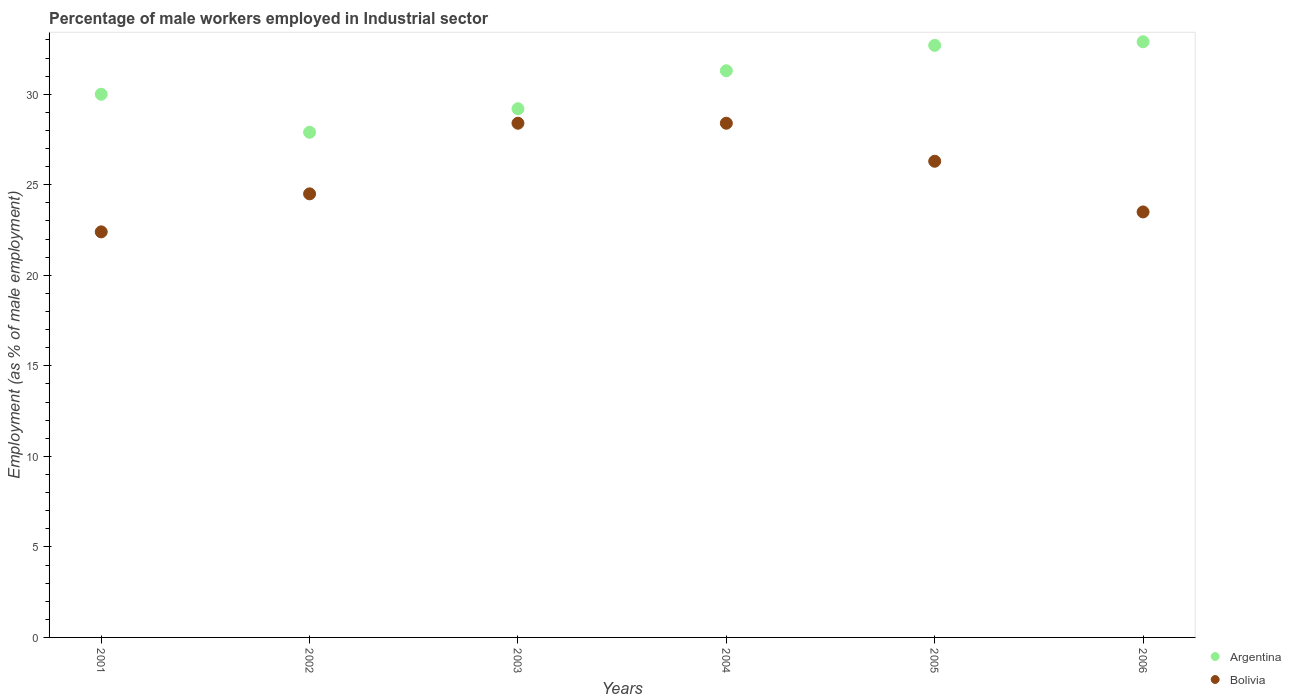How many different coloured dotlines are there?
Provide a succinct answer. 2. What is the percentage of male workers employed in Industrial sector in Argentina in 2003?
Keep it short and to the point. 29.2. Across all years, what is the maximum percentage of male workers employed in Industrial sector in Bolivia?
Your answer should be compact. 28.4. Across all years, what is the minimum percentage of male workers employed in Industrial sector in Bolivia?
Offer a terse response. 22.4. In which year was the percentage of male workers employed in Industrial sector in Bolivia maximum?
Offer a terse response. 2003. What is the total percentage of male workers employed in Industrial sector in Bolivia in the graph?
Offer a terse response. 153.5. What is the difference between the percentage of male workers employed in Industrial sector in Bolivia in 2002 and that in 2006?
Provide a succinct answer. 1. What is the difference between the percentage of male workers employed in Industrial sector in Bolivia in 2006 and the percentage of male workers employed in Industrial sector in Argentina in 2005?
Offer a terse response. -9.2. What is the average percentage of male workers employed in Industrial sector in Bolivia per year?
Your answer should be very brief. 25.58. In the year 2004, what is the difference between the percentage of male workers employed in Industrial sector in Bolivia and percentage of male workers employed in Industrial sector in Argentina?
Your answer should be very brief. -2.9. In how many years, is the percentage of male workers employed in Industrial sector in Argentina greater than 18 %?
Keep it short and to the point. 6. What is the ratio of the percentage of male workers employed in Industrial sector in Bolivia in 2002 to that in 2006?
Keep it short and to the point. 1.04. Is the percentage of male workers employed in Industrial sector in Bolivia in 2005 less than that in 2006?
Keep it short and to the point. No. What is the difference between the highest and the second highest percentage of male workers employed in Industrial sector in Bolivia?
Your answer should be compact. 0. What is the difference between the highest and the lowest percentage of male workers employed in Industrial sector in Bolivia?
Give a very brief answer. 6. Is the percentage of male workers employed in Industrial sector in Argentina strictly less than the percentage of male workers employed in Industrial sector in Bolivia over the years?
Ensure brevity in your answer.  No. How many years are there in the graph?
Offer a terse response. 6. Are the values on the major ticks of Y-axis written in scientific E-notation?
Provide a succinct answer. No. Where does the legend appear in the graph?
Make the answer very short. Bottom right. How are the legend labels stacked?
Provide a short and direct response. Vertical. What is the title of the graph?
Your response must be concise. Percentage of male workers employed in Industrial sector. What is the label or title of the Y-axis?
Your answer should be compact. Employment (as % of male employment). What is the Employment (as % of male employment) of Bolivia in 2001?
Your answer should be very brief. 22.4. What is the Employment (as % of male employment) of Argentina in 2002?
Your answer should be compact. 27.9. What is the Employment (as % of male employment) in Argentina in 2003?
Provide a short and direct response. 29.2. What is the Employment (as % of male employment) in Bolivia in 2003?
Offer a terse response. 28.4. What is the Employment (as % of male employment) in Argentina in 2004?
Your answer should be very brief. 31.3. What is the Employment (as % of male employment) of Bolivia in 2004?
Offer a terse response. 28.4. What is the Employment (as % of male employment) in Argentina in 2005?
Keep it short and to the point. 32.7. What is the Employment (as % of male employment) in Bolivia in 2005?
Provide a succinct answer. 26.3. What is the Employment (as % of male employment) in Argentina in 2006?
Offer a terse response. 32.9. What is the Employment (as % of male employment) in Bolivia in 2006?
Provide a succinct answer. 23.5. Across all years, what is the maximum Employment (as % of male employment) in Argentina?
Your answer should be very brief. 32.9. Across all years, what is the maximum Employment (as % of male employment) in Bolivia?
Provide a succinct answer. 28.4. Across all years, what is the minimum Employment (as % of male employment) of Argentina?
Your response must be concise. 27.9. Across all years, what is the minimum Employment (as % of male employment) in Bolivia?
Your response must be concise. 22.4. What is the total Employment (as % of male employment) of Argentina in the graph?
Offer a terse response. 184. What is the total Employment (as % of male employment) in Bolivia in the graph?
Keep it short and to the point. 153.5. What is the difference between the Employment (as % of male employment) in Bolivia in 2001 and that in 2002?
Provide a short and direct response. -2.1. What is the difference between the Employment (as % of male employment) of Bolivia in 2001 and that in 2003?
Offer a very short reply. -6. What is the difference between the Employment (as % of male employment) of Argentina in 2001 and that in 2004?
Your answer should be very brief. -1.3. What is the difference between the Employment (as % of male employment) in Bolivia in 2001 and that in 2006?
Your answer should be compact. -1.1. What is the difference between the Employment (as % of male employment) of Argentina in 2002 and that in 2003?
Provide a succinct answer. -1.3. What is the difference between the Employment (as % of male employment) in Bolivia in 2002 and that in 2003?
Offer a terse response. -3.9. What is the difference between the Employment (as % of male employment) of Bolivia in 2002 and that in 2005?
Offer a very short reply. -1.8. What is the difference between the Employment (as % of male employment) of Bolivia in 2003 and that in 2004?
Your response must be concise. 0. What is the difference between the Employment (as % of male employment) of Argentina in 2003 and that in 2005?
Your response must be concise. -3.5. What is the difference between the Employment (as % of male employment) of Bolivia in 2003 and that in 2005?
Your response must be concise. 2.1. What is the difference between the Employment (as % of male employment) in Bolivia in 2004 and that in 2006?
Keep it short and to the point. 4.9. What is the difference between the Employment (as % of male employment) in Argentina in 2005 and that in 2006?
Give a very brief answer. -0.2. What is the difference between the Employment (as % of male employment) in Argentina in 2001 and the Employment (as % of male employment) in Bolivia in 2003?
Provide a succinct answer. 1.6. What is the difference between the Employment (as % of male employment) of Argentina in 2001 and the Employment (as % of male employment) of Bolivia in 2004?
Your response must be concise. 1.6. What is the difference between the Employment (as % of male employment) in Argentina in 2001 and the Employment (as % of male employment) in Bolivia in 2005?
Make the answer very short. 3.7. What is the difference between the Employment (as % of male employment) in Argentina in 2001 and the Employment (as % of male employment) in Bolivia in 2006?
Offer a very short reply. 6.5. What is the difference between the Employment (as % of male employment) of Argentina in 2002 and the Employment (as % of male employment) of Bolivia in 2004?
Your answer should be very brief. -0.5. What is the difference between the Employment (as % of male employment) of Argentina in 2003 and the Employment (as % of male employment) of Bolivia in 2006?
Keep it short and to the point. 5.7. What is the average Employment (as % of male employment) in Argentina per year?
Offer a very short reply. 30.67. What is the average Employment (as % of male employment) of Bolivia per year?
Give a very brief answer. 25.58. In the year 2001, what is the difference between the Employment (as % of male employment) in Argentina and Employment (as % of male employment) in Bolivia?
Provide a succinct answer. 7.6. In the year 2002, what is the difference between the Employment (as % of male employment) of Argentina and Employment (as % of male employment) of Bolivia?
Your answer should be very brief. 3.4. In the year 2004, what is the difference between the Employment (as % of male employment) of Argentina and Employment (as % of male employment) of Bolivia?
Offer a terse response. 2.9. What is the ratio of the Employment (as % of male employment) of Argentina in 2001 to that in 2002?
Your answer should be very brief. 1.08. What is the ratio of the Employment (as % of male employment) in Bolivia in 2001 to that in 2002?
Give a very brief answer. 0.91. What is the ratio of the Employment (as % of male employment) in Argentina in 2001 to that in 2003?
Give a very brief answer. 1.03. What is the ratio of the Employment (as % of male employment) of Bolivia in 2001 to that in 2003?
Keep it short and to the point. 0.79. What is the ratio of the Employment (as % of male employment) of Argentina in 2001 to that in 2004?
Ensure brevity in your answer.  0.96. What is the ratio of the Employment (as % of male employment) of Bolivia in 2001 to that in 2004?
Ensure brevity in your answer.  0.79. What is the ratio of the Employment (as % of male employment) of Argentina in 2001 to that in 2005?
Provide a succinct answer. 0.92. What is the ratio of the Employment (as % of male employment) of Bolivia in 2001 to that in 2005?
Provide a short and direct response. 0.85. What is the ratio of the Employment (as % of male employment) in Argentina in 2001 to that in 2006?
Provide a succinct answer. 0.91. What is the ratio of the Employment (as % of male employment) of Bolivia in 2001 to that in 2006?
Make the answer very short. 0.95. What is the ratio of the Employment (as % of male employment) in Argentina in 2002 to that in 2003?
Provide a succinct answer. 0.96. What is the ratio of the Employment (as % of male employment) in Bolivia in 2002 to that in 2003?
Your answer should be compact. 0.86. What is the ratio of the Employment (as % of male employment) of Argentina in 2002 to that in 2004?
Provide a short and direct response. 0.89. What is the ratio of the Employment (as % of male employment) in Bolivia in 2002 to that in 2004?
Your response must be concise. 0.86. What is the ratio of the Employment (as % of male employment) of Argentina in 2002 to that in 2005?
Keep it short and to the point. 0.85. What is the ratio of the Employment (as % of male employment) in Bolivia in 2002 to that in 2005?
Provide a succinct answer. 0.93. What is the ratio of the Employment (as % of male employment) of Argentina in 2002 to that in 2006?
Your response must be concise. 0.85. What is the ratio of the Employment (as % of male employment) of Bolivia in 2002 to that in 2006?
Provide a succinct answer. 1.04. What is the ratio of the Employment (as % of male employment) of Argentina in 2003 to that in 2004?
Provide a succinct answer. 0.93. What is the ratio of the Employment (as % of male employment) in Bolivia in 2003 to that in 2004?
Provide a short and direct response. 1. What is the ratio of the Employment (as % of male employment) of Argentina in 2003 to that in 2005?
Your answer should be very brief. 0.89. What is the ratio of the Employment (as % of male employment) in Bolivia in 2003 to that in 2005?
Your answer should be compact. 1.08. What is the ratio of the Employment (as % of male employment) of Argentina in 2003 to that in 2006?
Give a very brief answer. 0.89. What is the ratio of the Employment (as % of male employment) of Bolivia in 2003 to that in 2006?
Your answer should be compact. 1.21. What is the ratio of the Employment (as % of male employment) of Argentina in 2004 to that in 2005?
Your response must be concise. 0.96. What is the ratio of the Employment (as % of male employment) in Bolivia in 2004 to that in 2005?
Make the answer very short. 1.08. What is the ratio of the Employment (as % of male employment) of Argentina in 2004 to that in 2006?
Provide a succinct answer. 0.95. What is the ratio of the Employment (as % of male employment) of Bolivia in 2004 to that in 2006?
Give a very brief answer. 1.21. What is the ratio of the Employment (as % of male employment) in Bolivia in 2005 to that in 2006?
Offer a very short reply. 1.12. What is the difference between the highest and the second highest Employment (as % of male employment) of Argentina?
Make the answer very short. 0.2. What is the difference between the highest and the lowest Employment (as % of male employment) of Argentina?
Make the answer very short. 5. What is the difference between the highest and the lowest Employment (as % of male employment) of Bolivia?
Your answer should be compact. 6. 